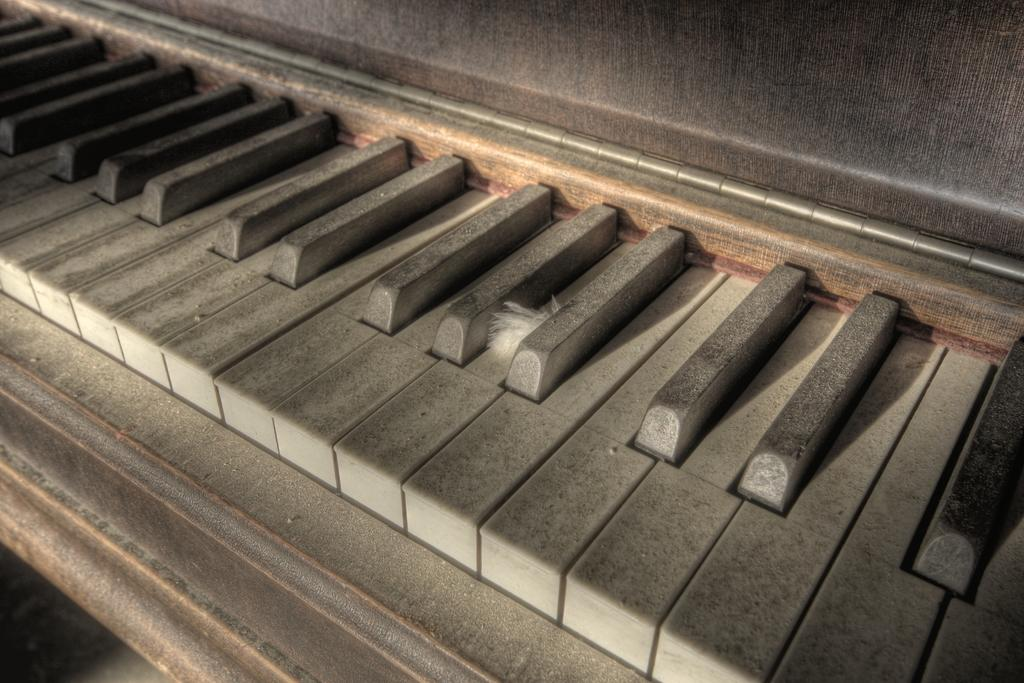What is the main object in the image? There is a piano in the image. Is there anything unusual on the piano? Yes, there is a feather on the piano. How many apples are on the piano in the image? There are no apples present in the image; only a piano and a feather are visible. 